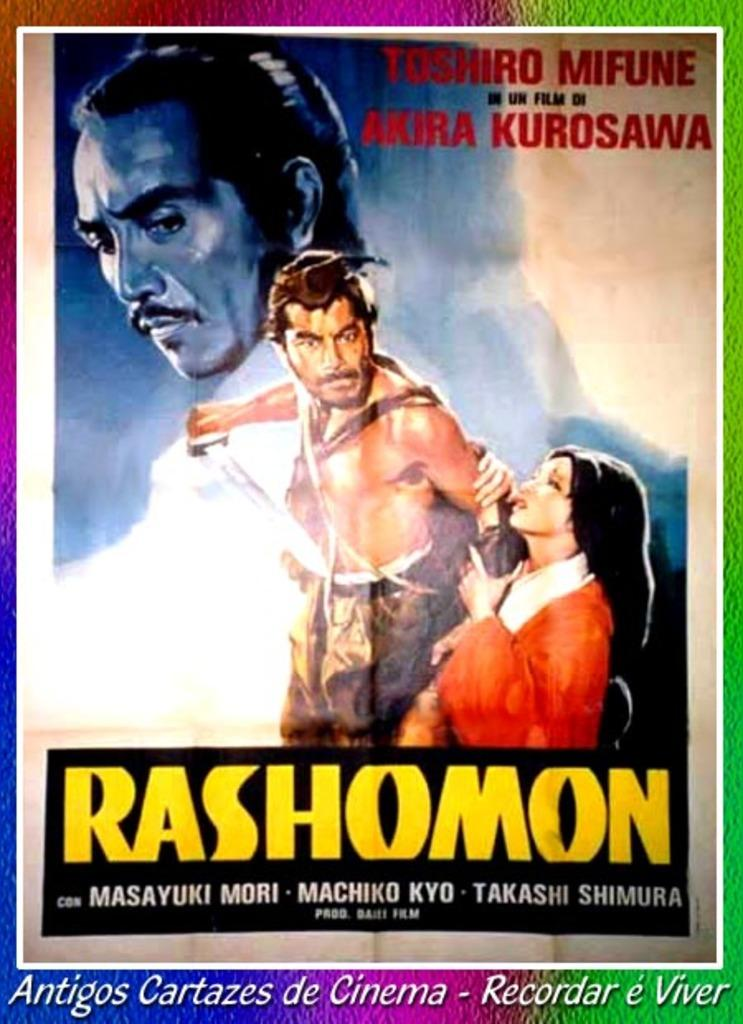<image>
Create a compact narrative representing the image presented. A movie poster for a vintage foreign movie called Rashomon. 